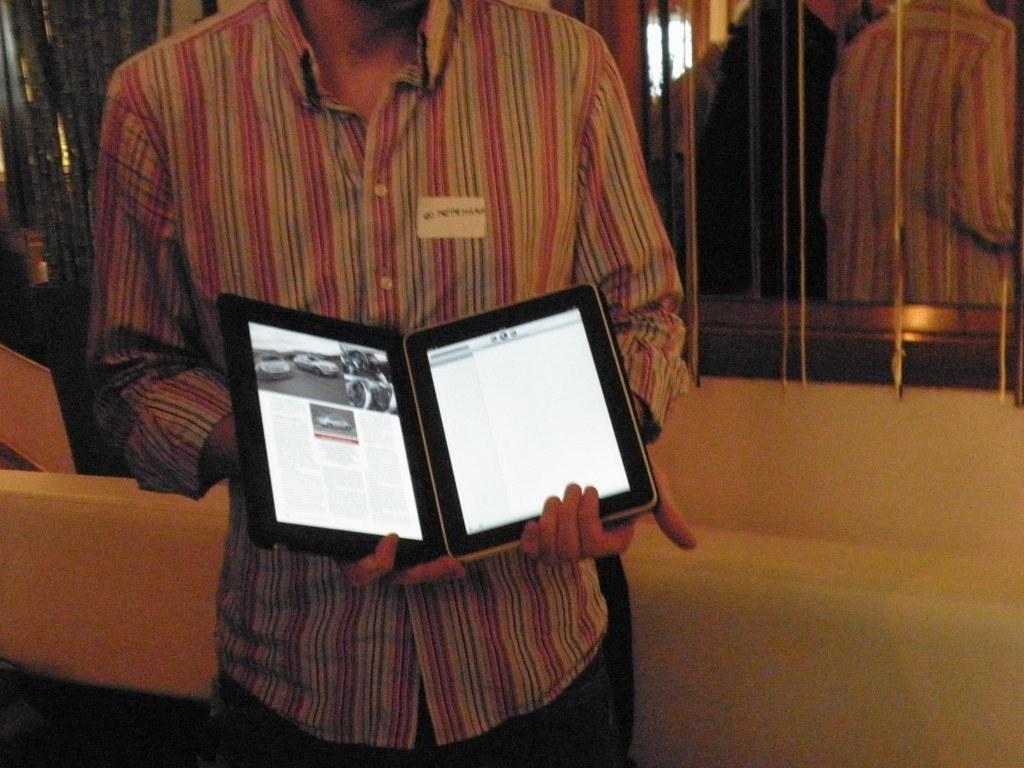Could you give a brief overview of what you see in this image? In the center of the image we can see one person is standing and holding one tab. On the screen, we can see cars, etc. In the background there is a wall, board, two persons are standing and few other objects. 